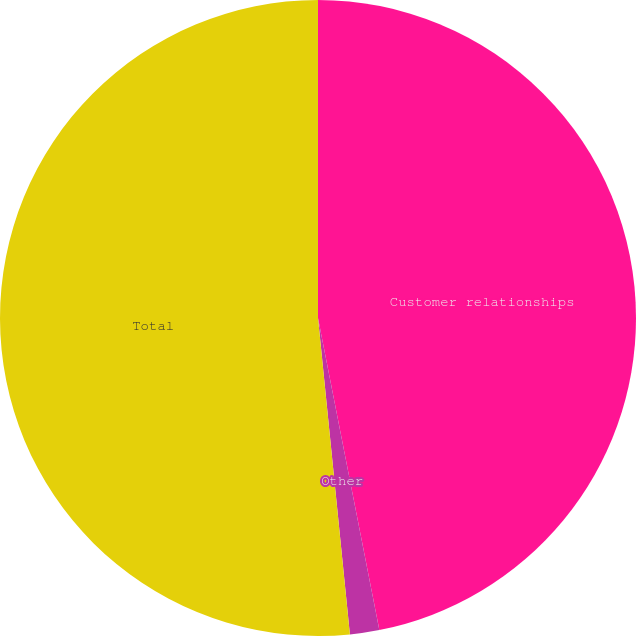Convert chart to OTSL. <chart><loc_0><loc_0><loc_500><loc_500><pie_chart><fcel>Customer relationships<fcel>Other<fcel>Total<nl><fcel>46.91%<fcel>1.49%<fcel>51.6%<nl></chart> 